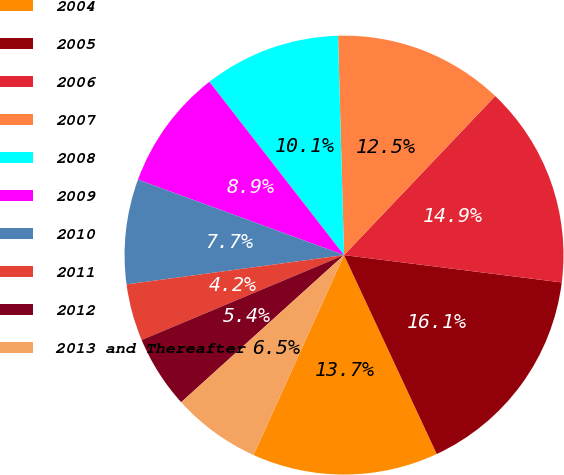Convert chart. <chart><loc_0><loc_0><loc_500><loc_500><pie_chart><fcel>2004<fcel>2005<fcel>2006<fcel>2007<fcel>2008<fcel>2009<fcel>2010<fcel>2011<fcel>2012<fcel>2013 and Thereafter<nl><fcel>13.71%<fcel>16.07%<fcel>14.89%<fcel>12.53%<fcel>10.08%<fcel>8.9%<fcel>7.72%<fcel>4.19%<fcel>5.37%<fcel>6.54%<nl></chart> 